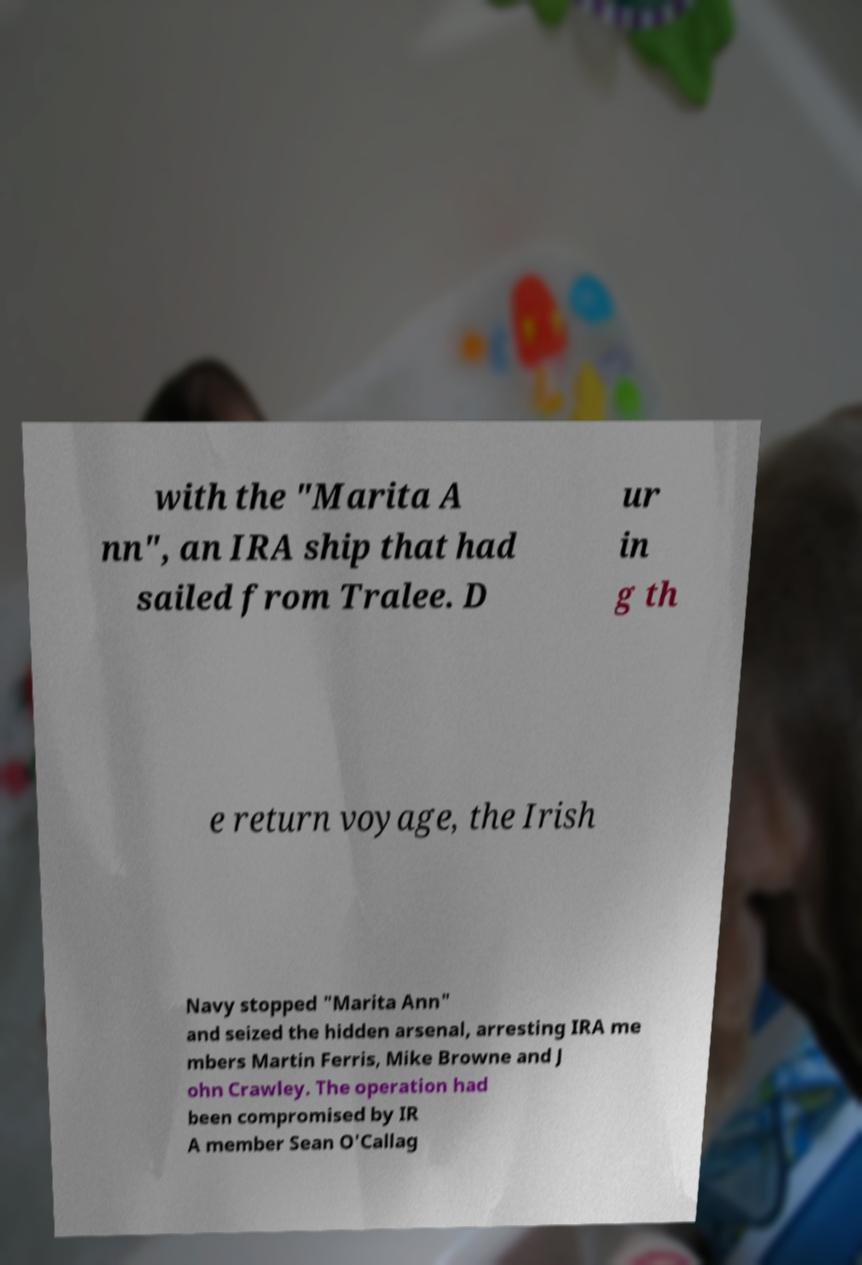What messages or text are displayed in this image? I need them in a readable, typed format. with the "Marita A nn", an IRA ship that had sailed from Tralee. D ur in g th e return voyage, the Irish Navy stopped "Marita Ann" and seized the hidden arsenal, arresting IRA me mbers Martin Ferris, Mike Browne and J ohn Crawley. The operation had been compromised by IR A member Sean O'Callag 